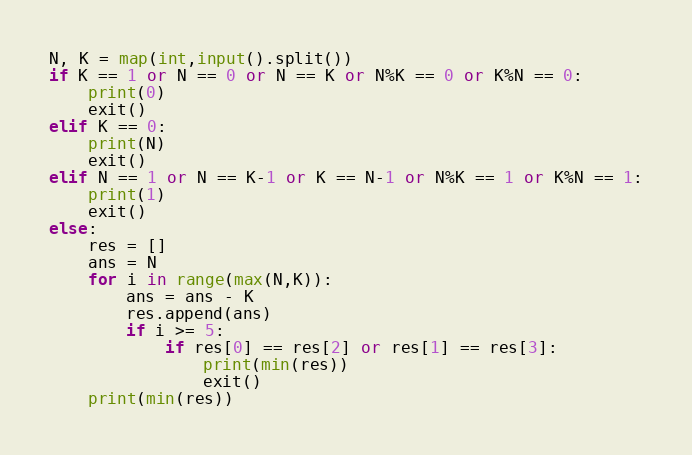Convert code to text. <code><loc_0><loc_0><loc_500><loc_500><_Python_>N, K = map(int,input().split())
if K == 1 or N == 0 or N == K or N%K == 0 or K%N == 0:
    print(0)
    exit()
elif K == 0:
    print(N)
    exit()
elif N == 1 or N == K-1 or K == N-1 or N%K == 1 or K%N == 1:
    print(1)
    exit()
else:
    res = []
    ans = N
    for i in range(max(N,K)):
        ans = ans - K
        res.append(ans)
        if i >= 5:
            if res[0] == res[2] or res[1] == res[3]:
                print(min(res))
                exit()
    print(min(res))</code> 